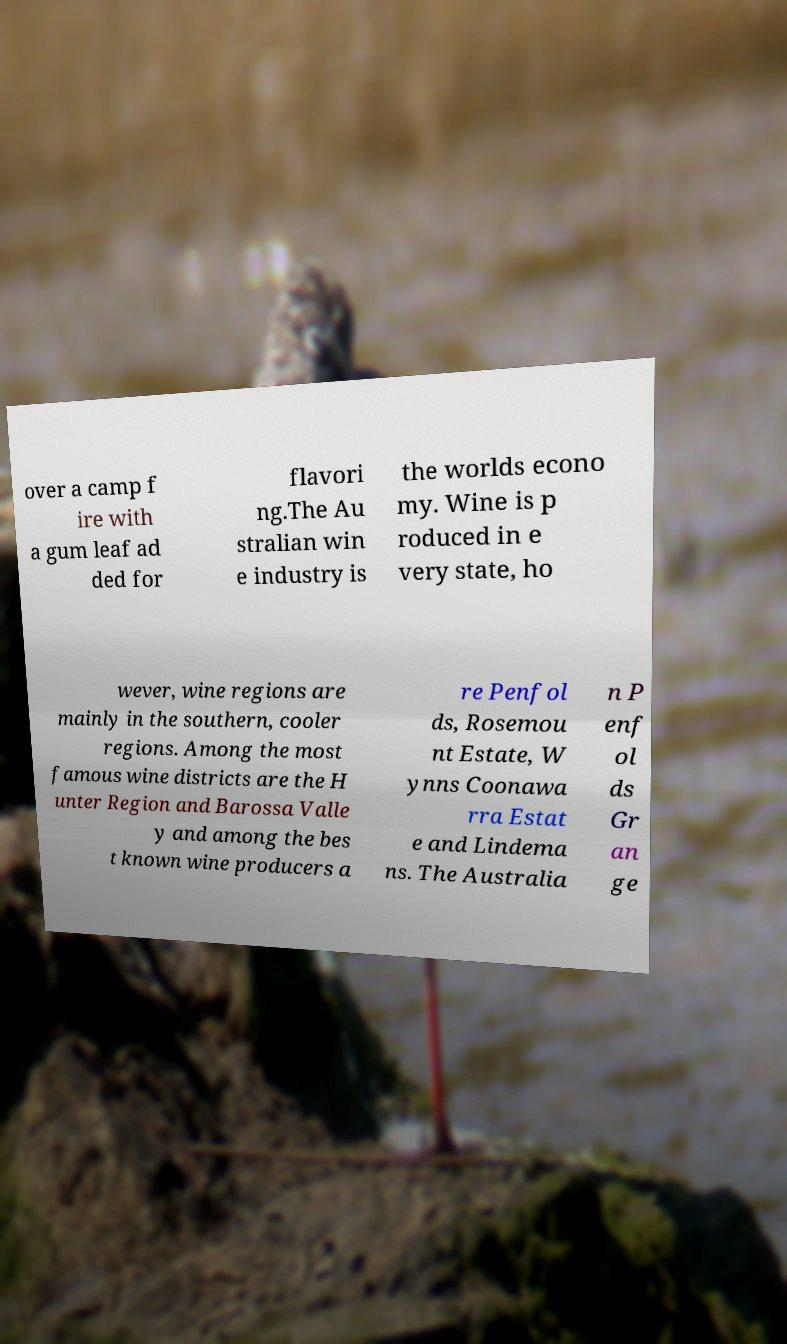For documentation purposes, I need the text within this image transcribed. Could you provide that? over a camp f ire with a gum leaf ad ded for flavori ng.The Au stralian win e industry is the worlds econo my. Wine is p roduced in e very state, ho wever, wine regions are mainly in the southern, cooler regions. Among the most famous wine districts are the H unter Region and Barossa Valle y and among the bes t known wine producers a re Penfol ds, Rosemou nt Estate, W ynns Coonawa rra Estat e and Lindema ns. The Australia n P enf ol ds Gr an ge 